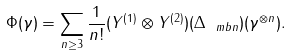<formula> <loc_0><loc_0><loc_500><loc_500>\Phi ( \gamma ) = \sum _ { n \geq 3 } \frac { 1 } { n ! } ( Y ^ { ( 1 ) } \otimes Y ^ { ( 2 ) } ) ( \Delta _ { \ m b n } ) ( \gamma ^ { \otimes n } ) .</formula> 